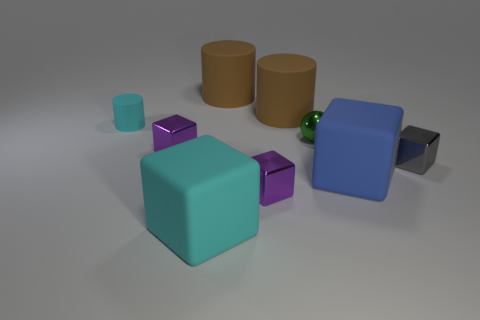Subtract all blue blocks. How many blocks are left? 4 Subtract all cyan rubber blocks. How many blocks are left? 4 Subtract all brown cubes. Subtract all green spheres. How many cubes are left? 5 Add 1 cylinders. How many objects exist? 10 Subtract all spheres. How many objects are left? 8 Add 4 small cylinders. How many small cylinders are left? 5 Add 3 green metallic spheres. How many green metallic spheres exist? 4 Subtract 1 brown cylinders. How many objects are left? 8 Subtract all tiny purple cubes. Subtract all tiny matte things. How many objects are left? 6 